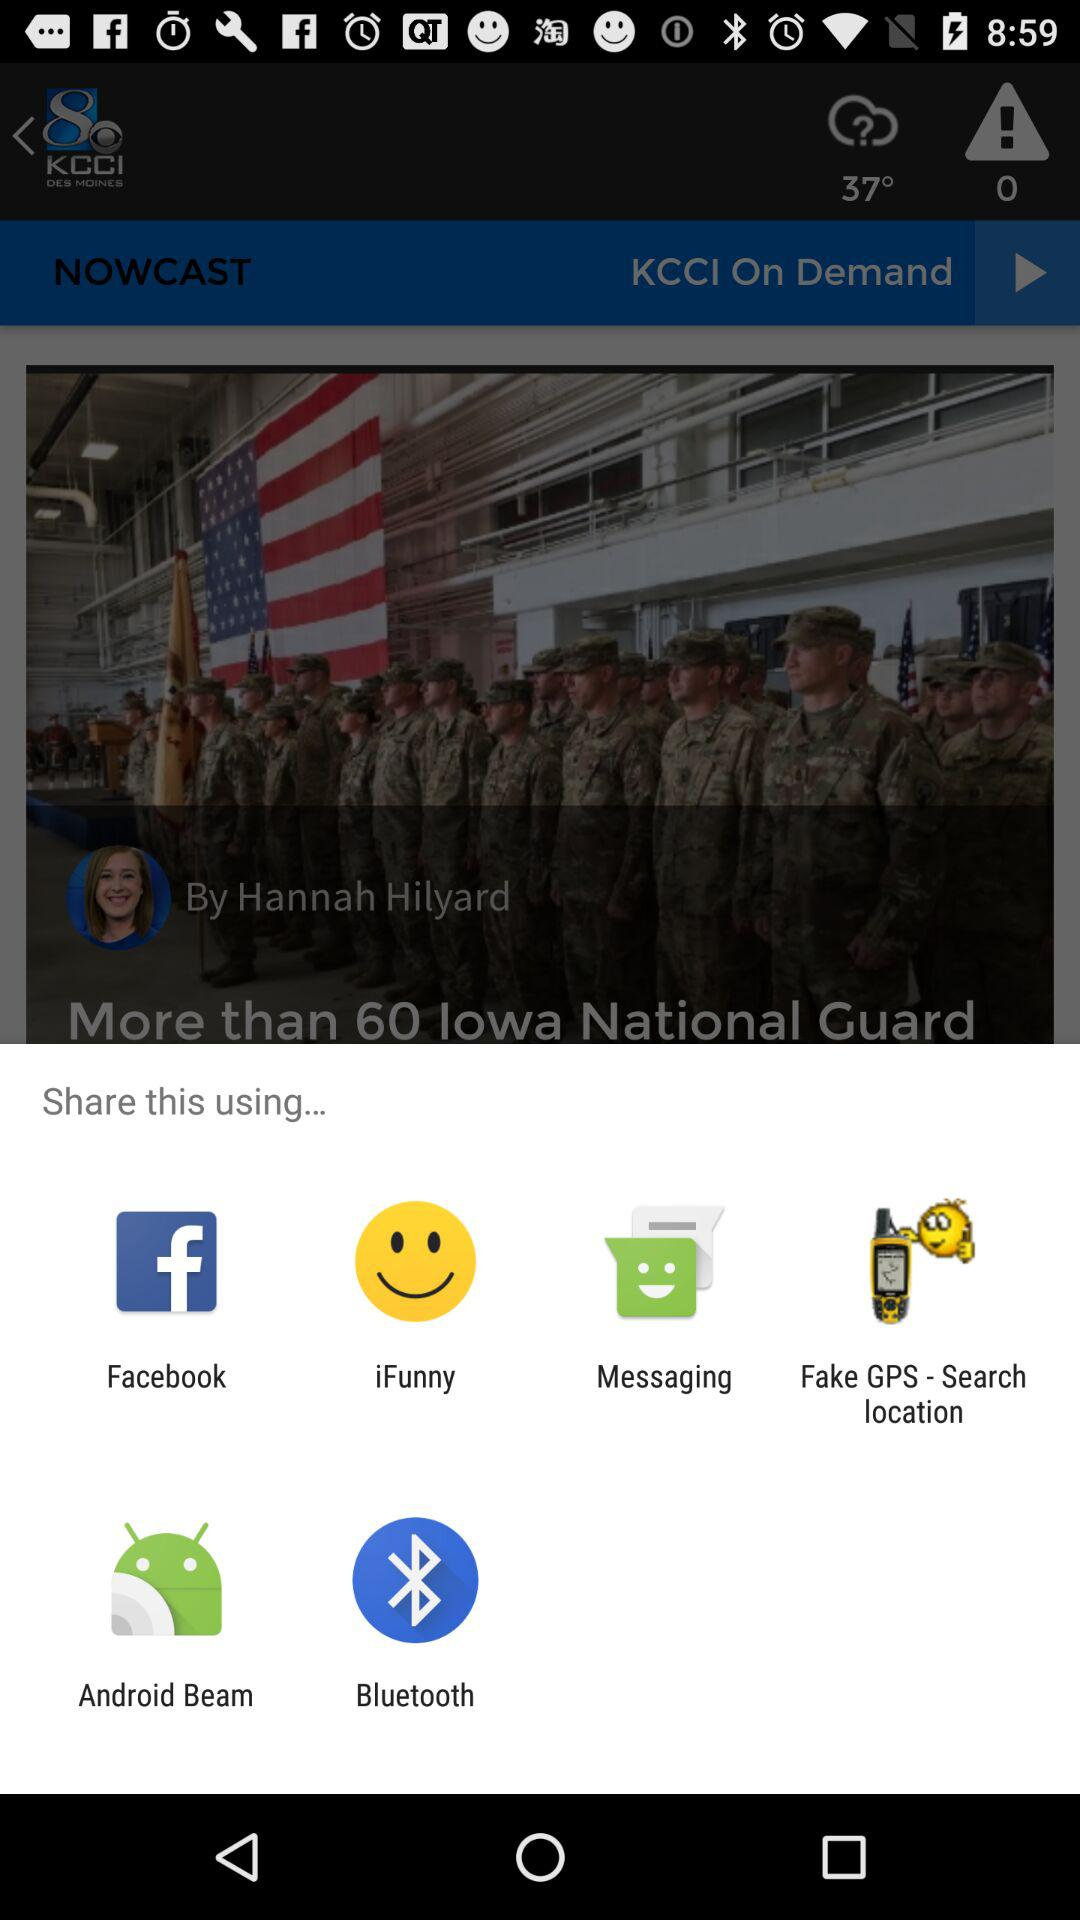Through which applications can we share the content? You can share the content through "Facebook", "iFunny", "Messaging", "Fake GPS - Search location", "Android Beam" and "Bluetooth". 